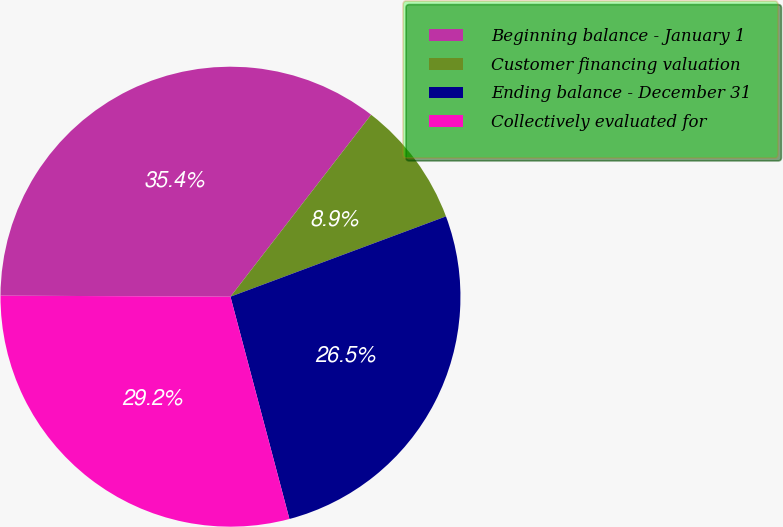Convert chart. <chart><loc_0><loc_0><loc_500><loc_500><pie_chart><fcel>Beginning balance - January 1<fcel>Customer financing valuation<fcel>Ending balance - December 31<fcel>Collectively evaluated for<nl><fcel>35.4%<fcel>8.85%<fcel>26.55%<fcel>29.2%<nl></chart> 